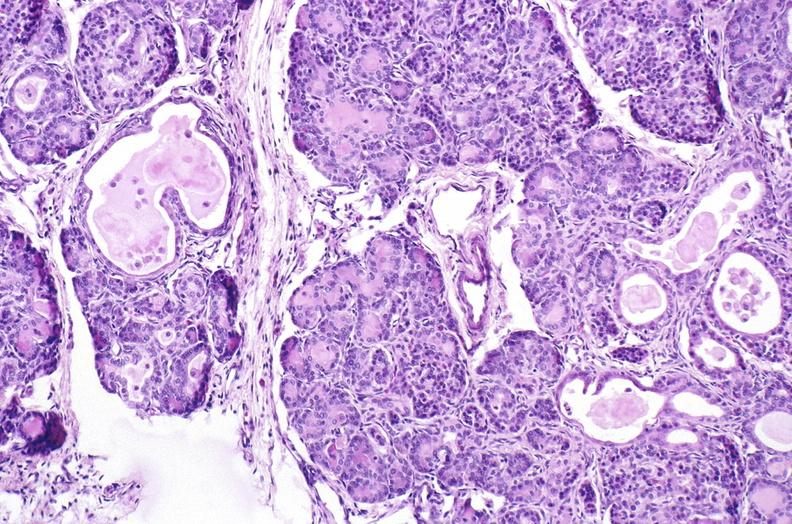does this image show cystic fibrosis?
Answer the question using a single word or phrase. Yes 